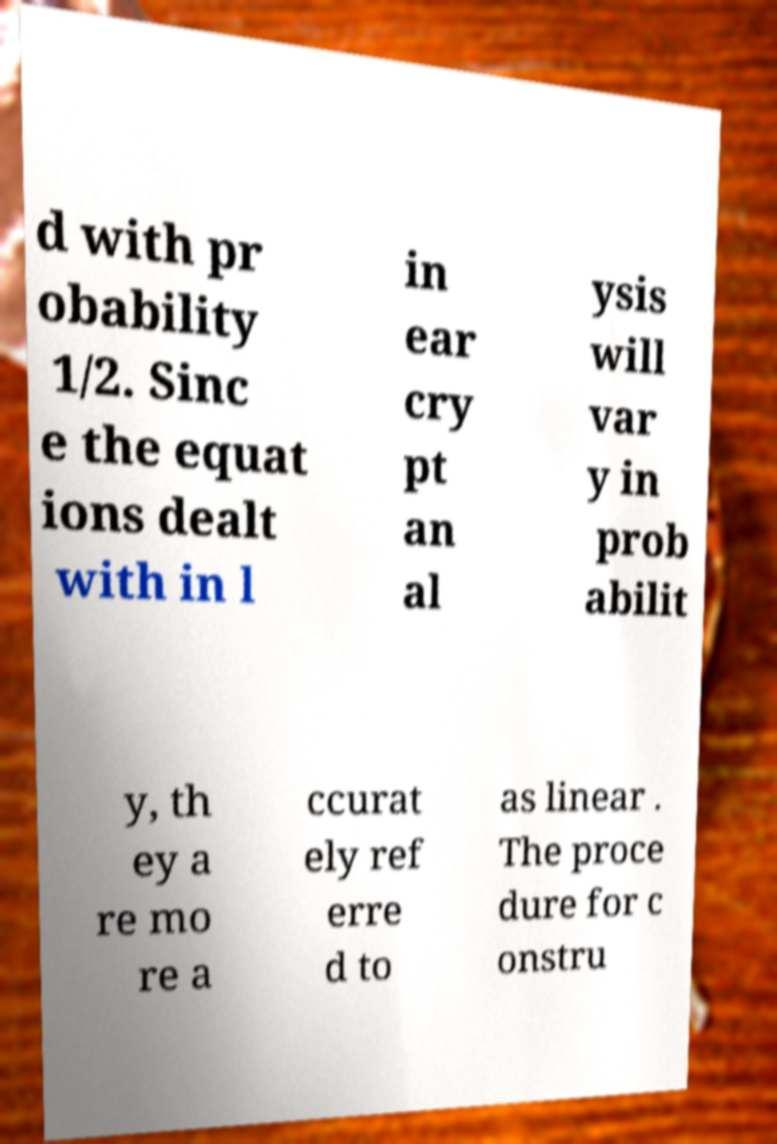I need the written content from this picture converted into text. Can you do that? d with pr obability 1/2. Sinc e the equat ions dealt with in l in ear cry pt an al ysis will var y in prob abilit y, th ey a re mo re a ccurat ely ref erre d to as linear . The proce dure for c onstru 